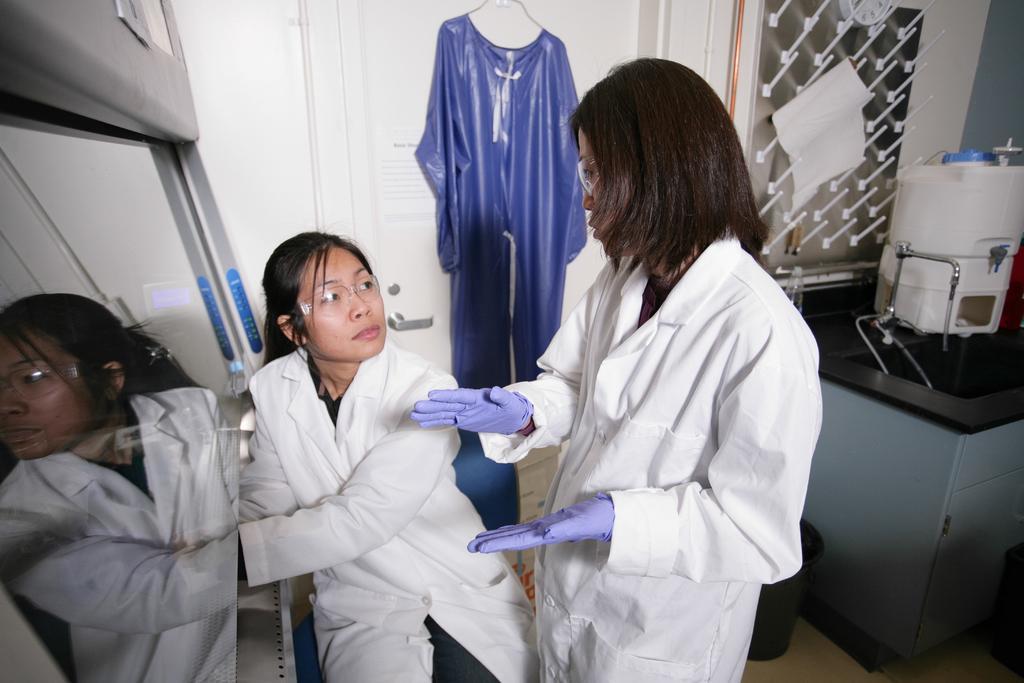Describe this image in one or two sentences. In this picture I can observe two women in the middle of the picture. They are wearing white color aprons and gloves to their hands. On the right side I can observe sink. In the background I can observe white color door. 